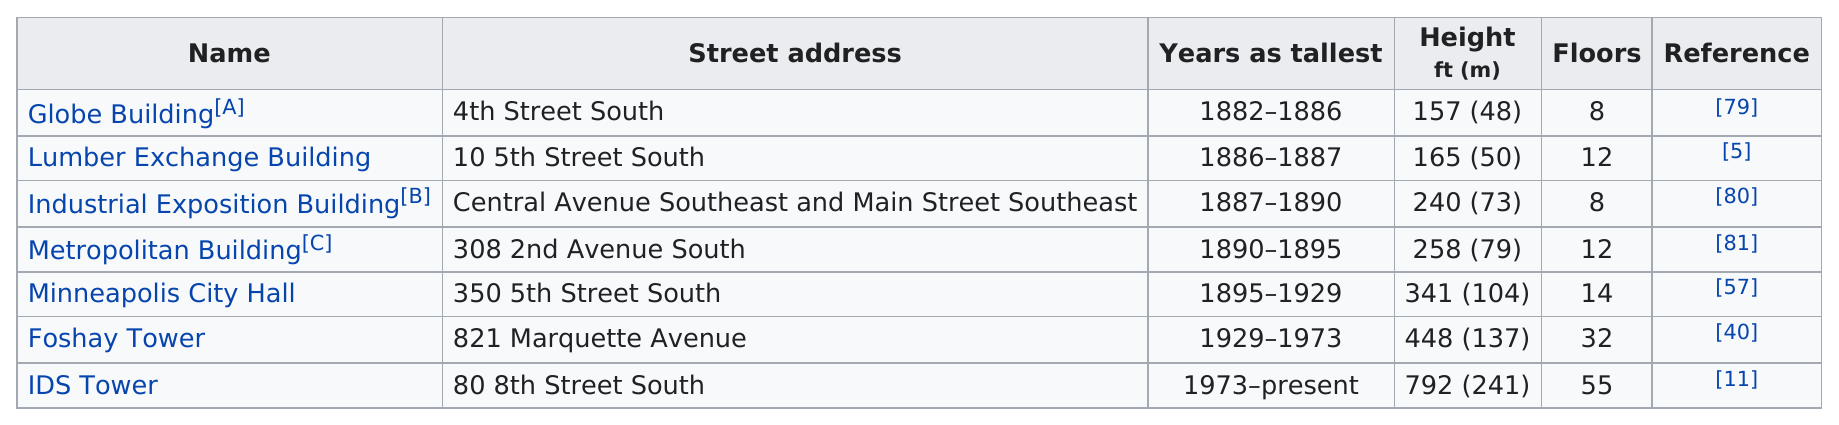Point out several critical features in this image. The Metropolitan Building or the Lumber Exchange Building is taller. Five buildings on the list are taller than 200 feet. The height of the IDS Tower is 792 feet. The Foshay Tower has 32 floors. After the IDS Tower, which is the tallest building in Minneapolis, the second tallest building is the Foshay Tower. 